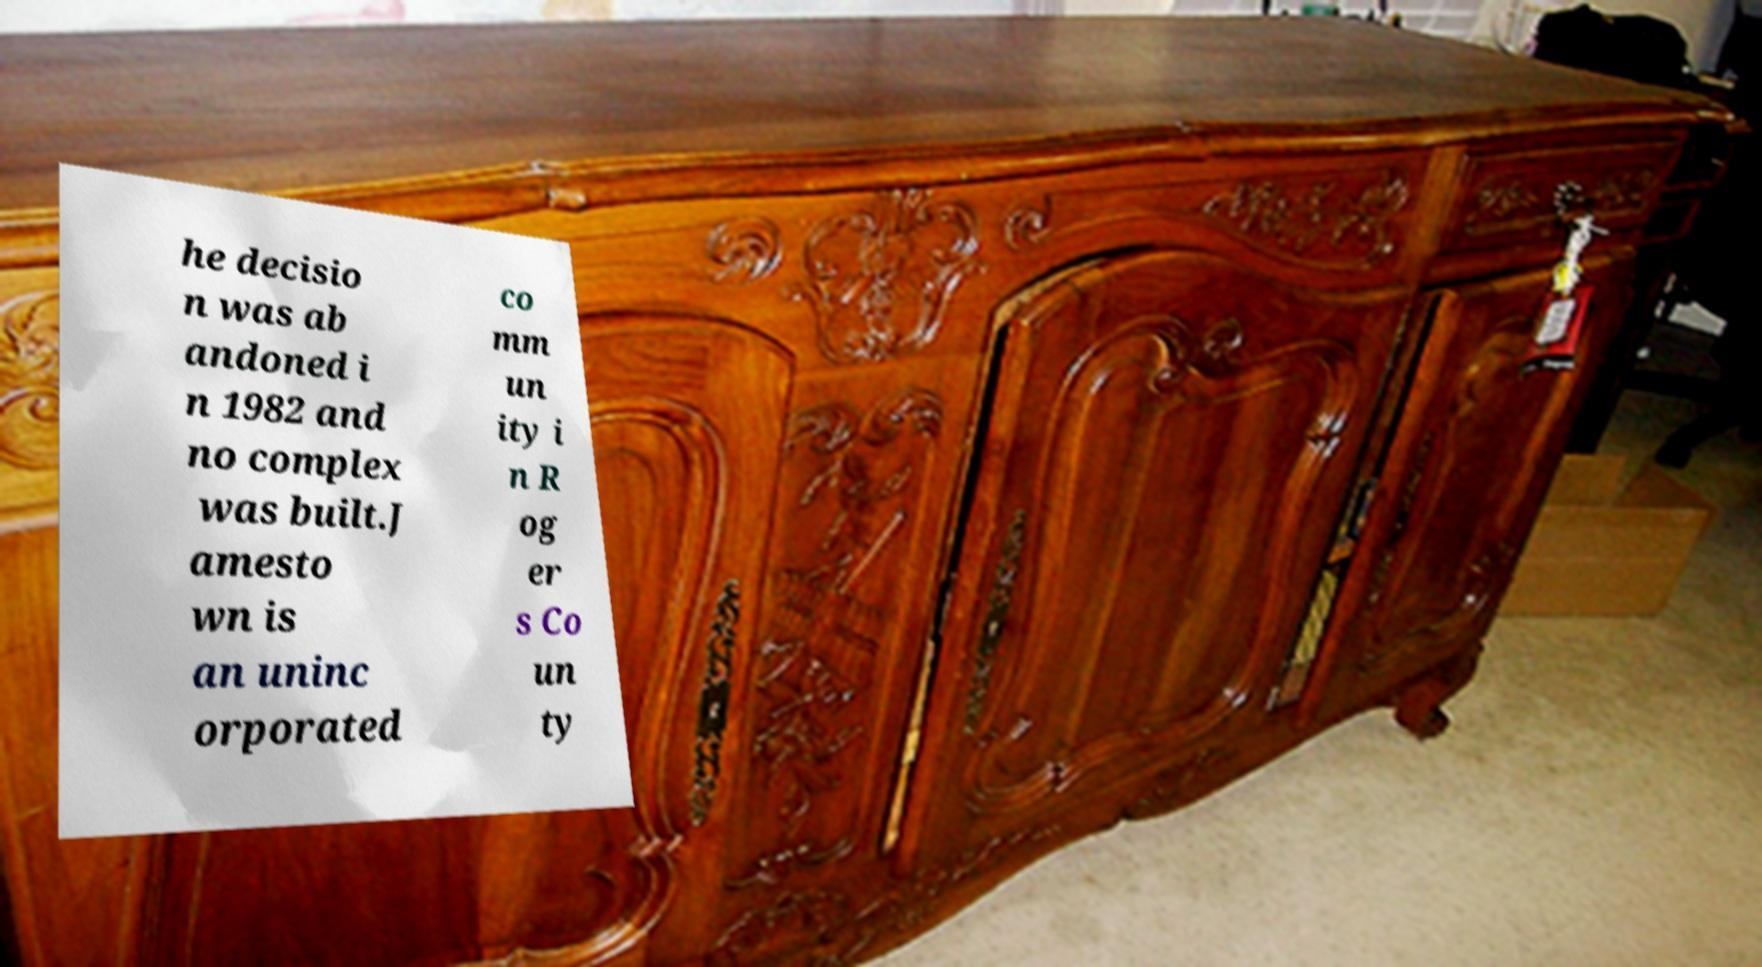Please read and relay the text visible in this image. What does it say? he decisio n was ab andoned i n 1982 and no complex was built.J amesto wn is an uninc orporated co mm un ity i n R og er s Co un ty 